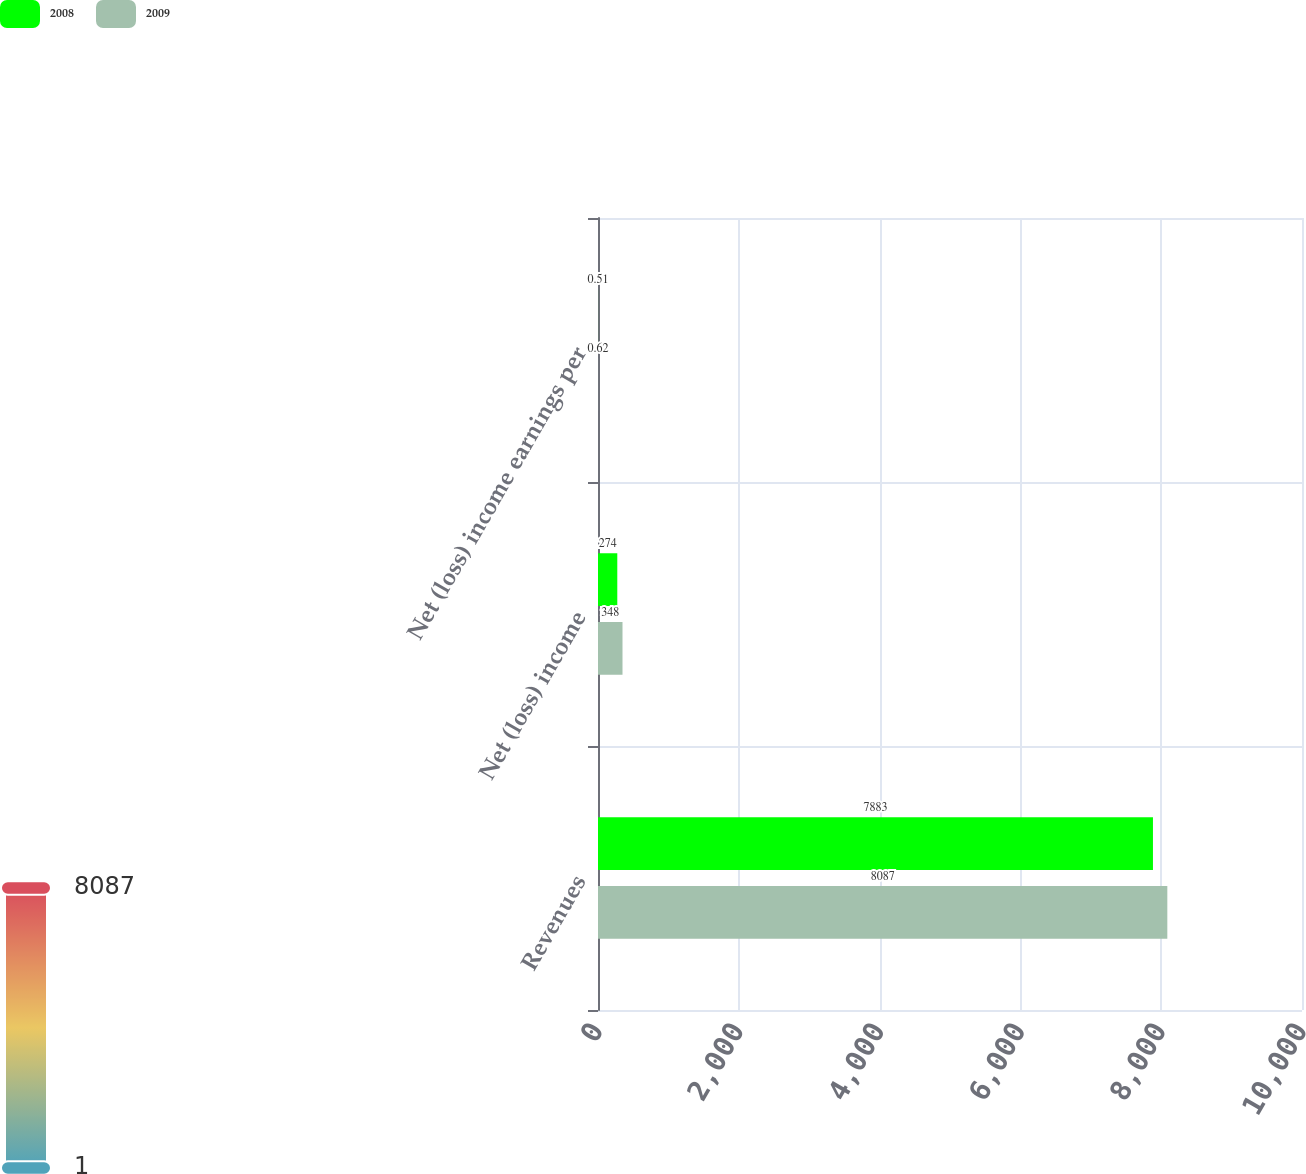Convert chart. <chart><loc_0><loc_0><loc_500><loc_500><stacked_bar_chart><ecel><fcel>Revenues<fcel>Net (loss) income<fcel>Net (loss) income earnings per<nl><fcel>2008<fcel>7883<fcel>274<fcel>0.51<nl><fcel>2009<fcel>8087<fcel>348<fcel>0.62<nl></chart> 